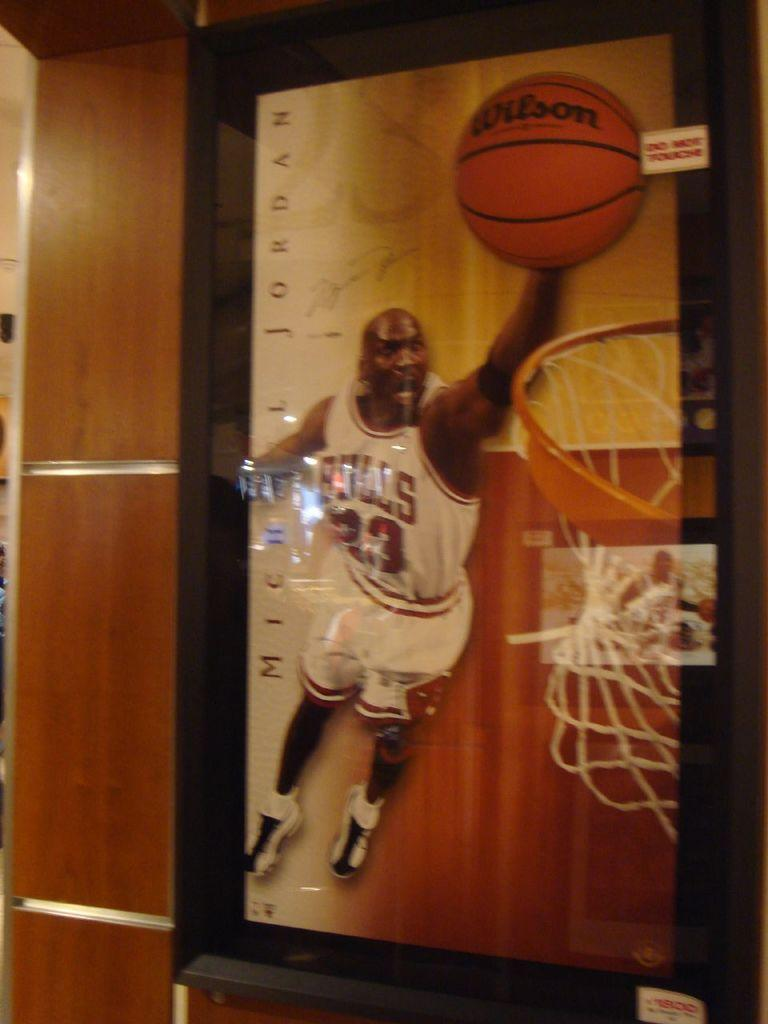<image>
Write a terse but informative summary of the picture. Poster of a basketball player wearing the number 23. 